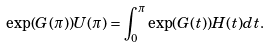<formula> <loc_0><loc_0><loc_500><loc_500>\exp ( G ( \pi ) ) U ( \pi ) = \int _ { 0 } ^ { \pi } \exp ( G ( t ) ) H ( t ) d t .</formula> 